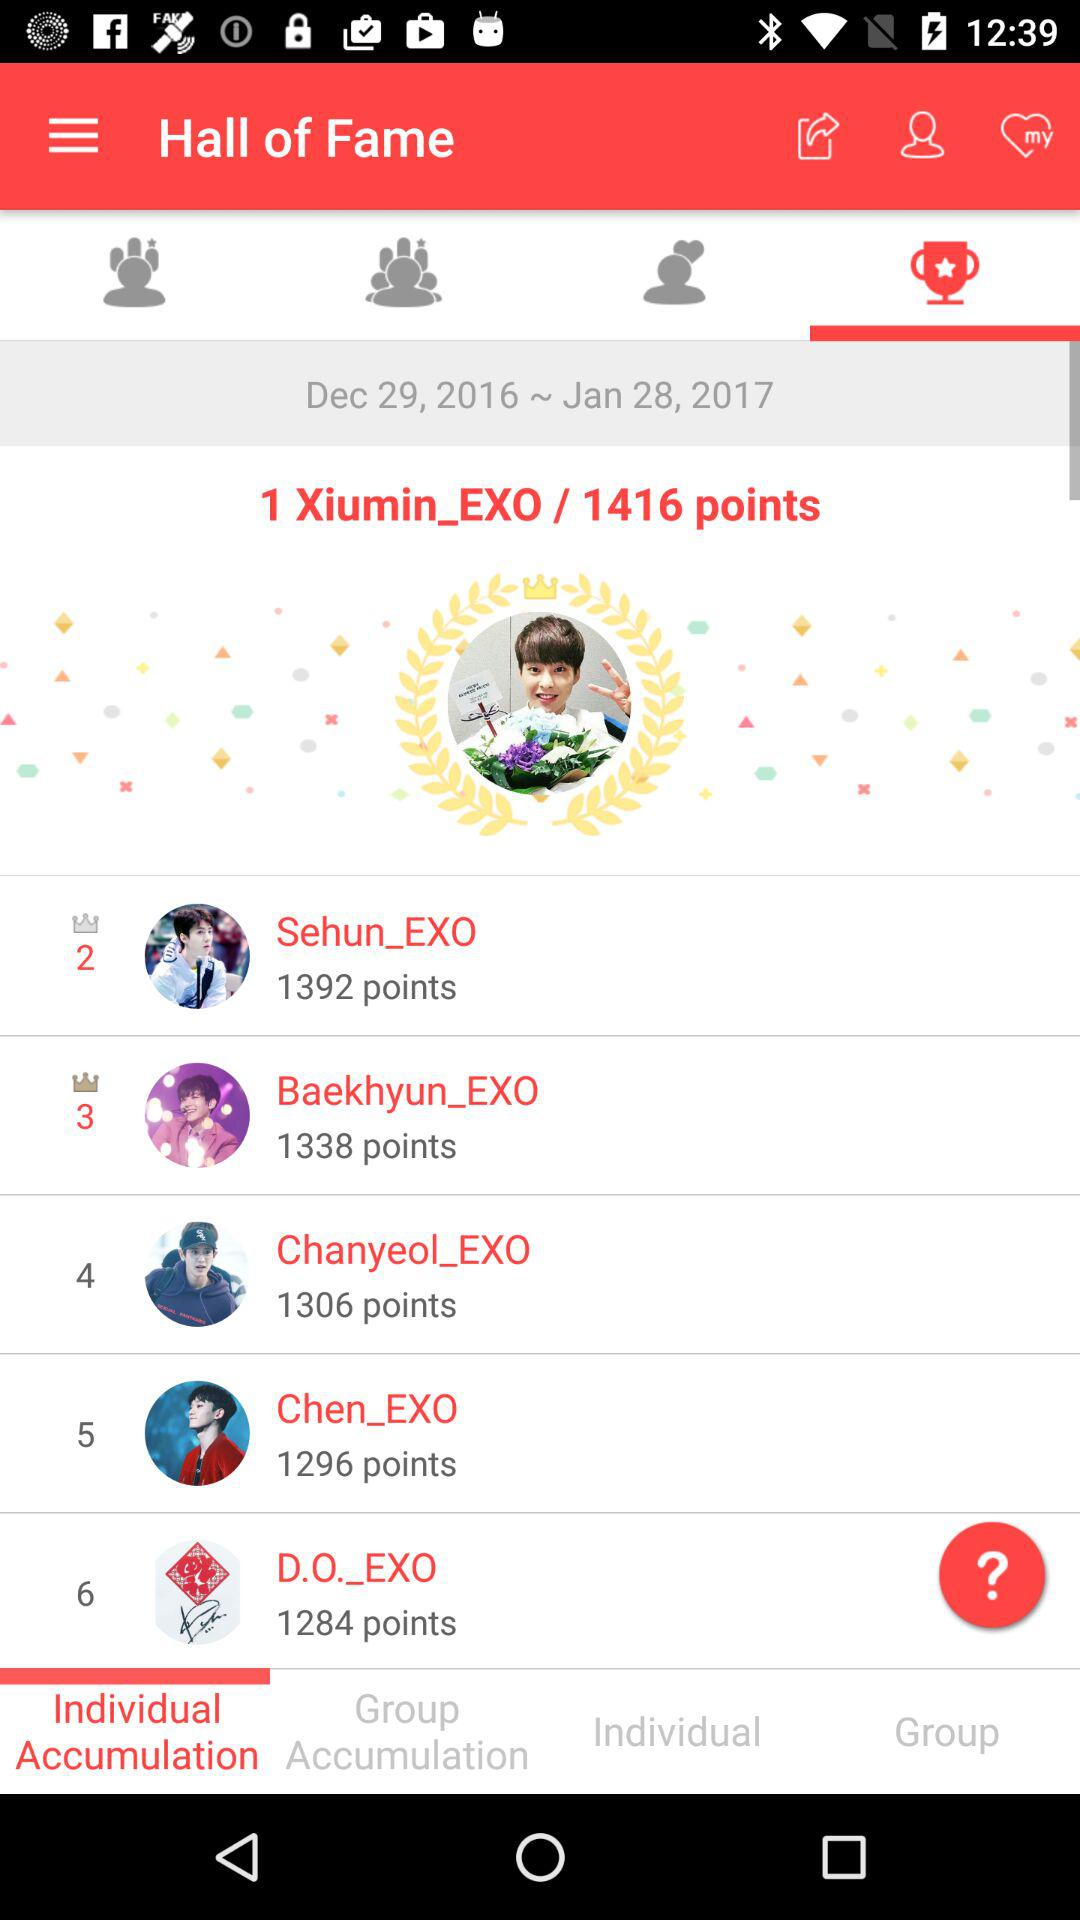Who secured the first place? The first place was secured by "Xiumin_EXO". 